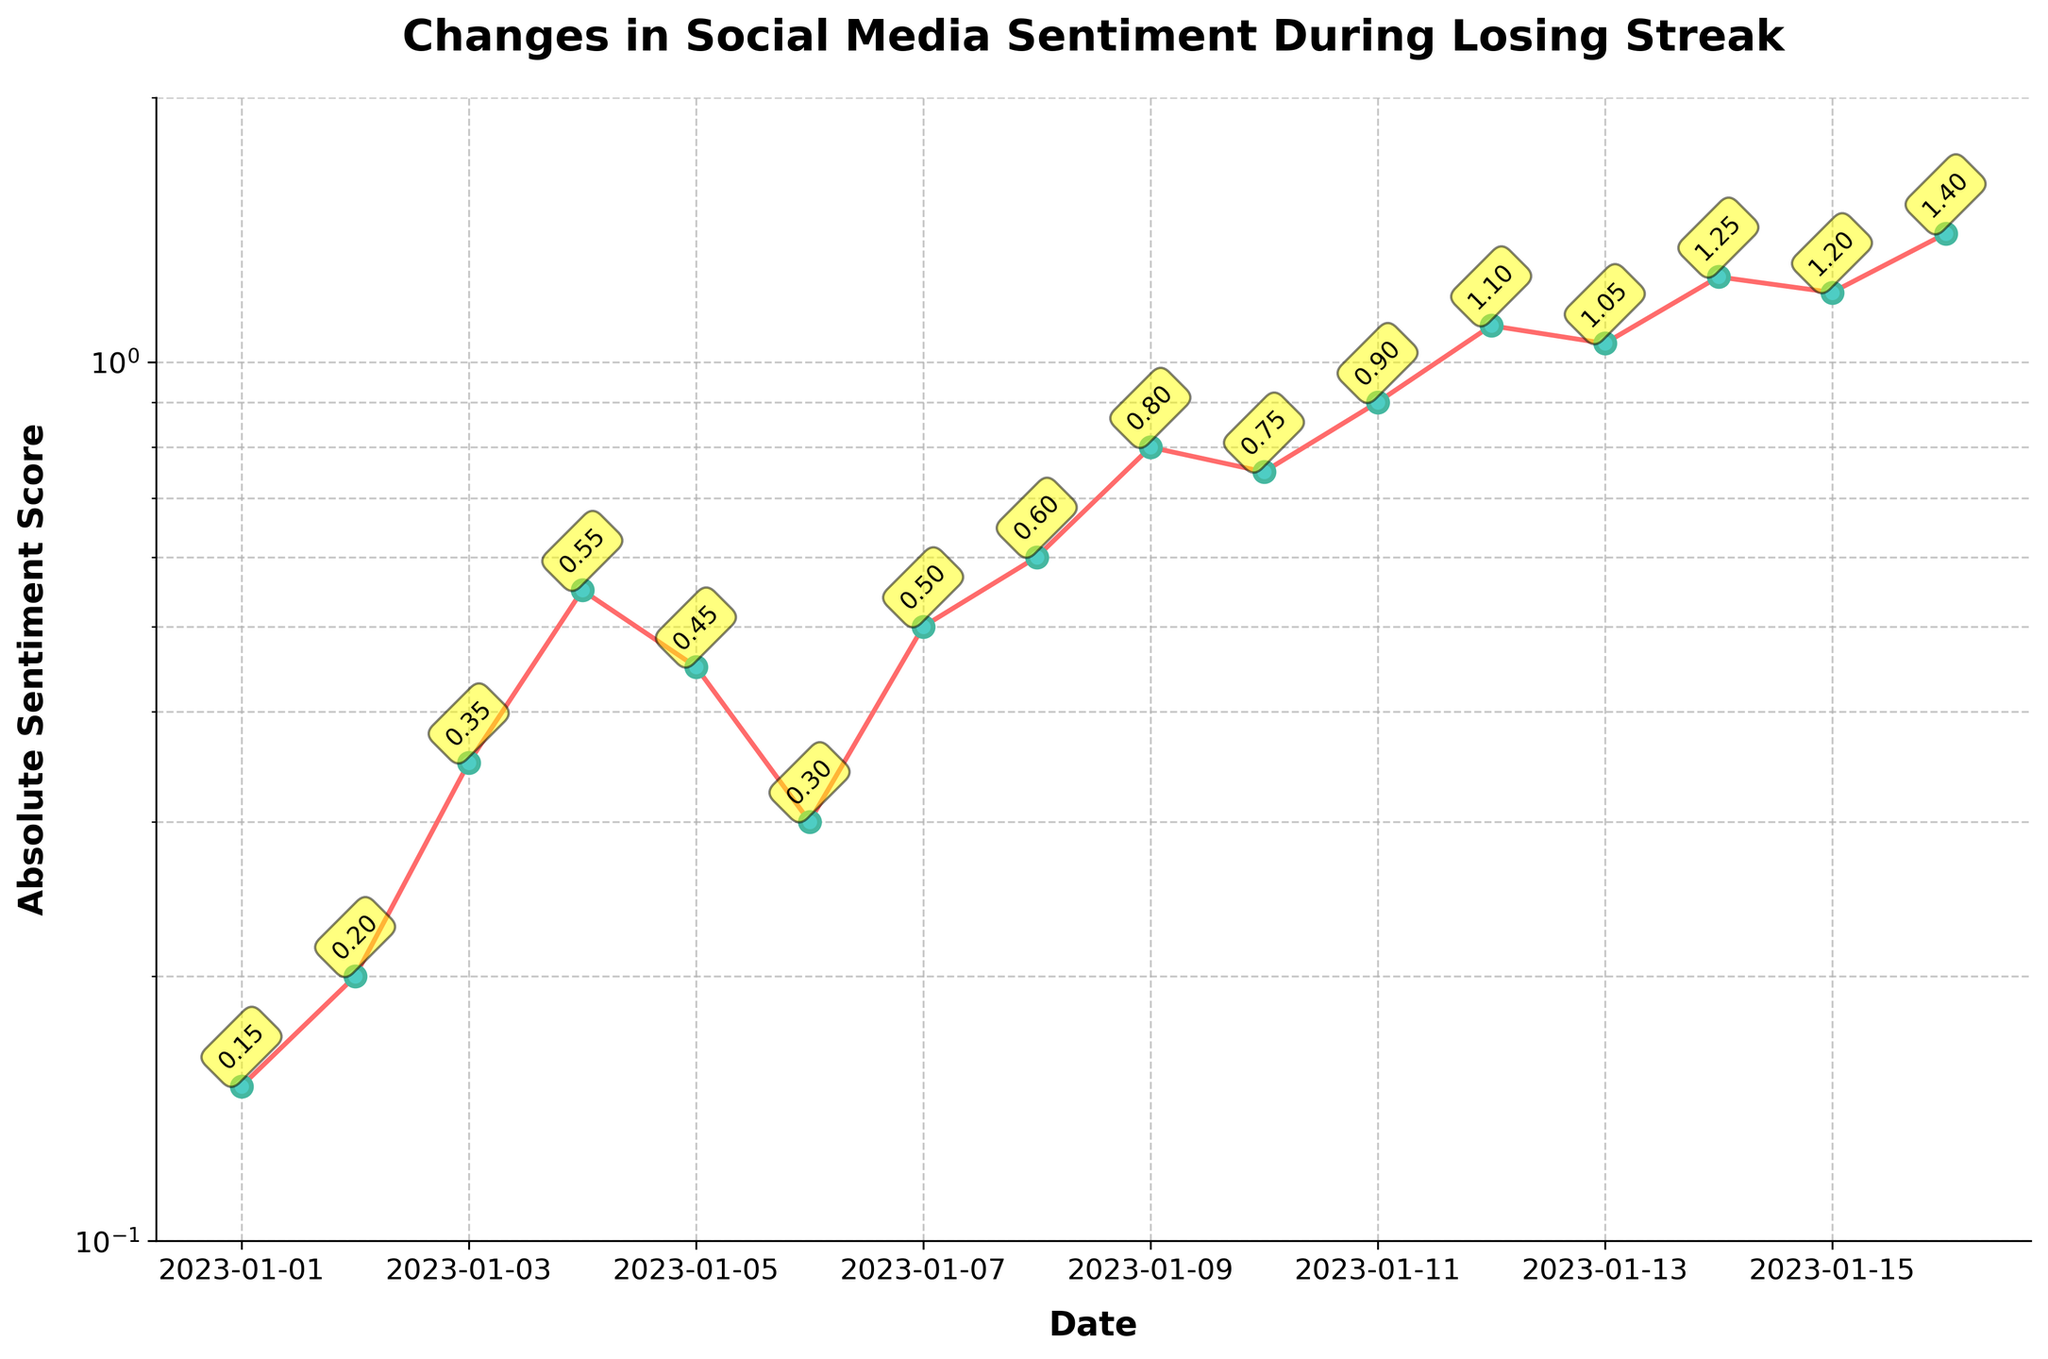What is the title of the plot? The title of the plot is located at the top and reads "Changes in Social Media Sentiment During Losing Streak".
Answer: Changes in Social Media Sentiment During Losing Streak What are the labels on the x-axis and y-axis? The x-axis label is "Date" and the y-axis label is "Absolute Sentiment Score".
Answer: Date and Absolute Sentiment Score How many data points are plotted on the graph? There are date markers from January 1st, 2023 to January 16th, 2023 on the x-axis, indicating that there are 16 data points plotted.
Answer: 16 Which color are the line and markers? The line is red, and the markers are cyan with green edges.
Answer: Red and Cyan What is the y-scale used in the plot? The y-axis of the plot uses a log scale, as indicated by the logarithmic spacing of the tick marks.
Answer: Log scale What is the average absolute sentiment score over the first 5 days? Averaging the absolute sentiment scores for the first five dates (0.15 + 0.20 + 0.35 + 0.55 + 0.45) gives (0.15 + 0.20 + 0.35 + 0.55 + 0.45)/5 = 0.34.
Answer: 0.34 What is the difference in absolute sentiment score between January 12th and January 1st? The absolute sentiment score on January 12th is 1.10 and on January 1st is 0.15. The difference is 1.10 - 0.15 = 0.95.
Answer: 0.95 On what date does the absolute sentiment score first exceed 1.0? The plot shows that the absolute sentiment score first exceeds 1.0 on January 12th, 2023.
Answer: January 12th, 2023 Which day shows the highest absolute sentiment score? The highest absolute sentiment score on the plot is recorded on January 16th, 2023, with a value of 1.40.
Answer: January 16th, 2023 Between January 6th and January 8th, which day has the highest absolute sentiment score? The absolute sentiment scores on January 6th, January 7th, and January 8th are 0.30, 0.50, and 0.60 respectively. January 8th has the highest absolute sentiment score.
Answer: January 8th How does the absolute sentiment score change as the losing streak progresses? The absolute sentiment score generally increases as the losing streak progresses, which is indicative of worsening or increasingly negative sentiment over time.
Answer: Increases How does the log scale on the y-axis affect the appearance of the changes in sentiment scores over time? The log scale on the y-axis makes changes in sentiment scores near the lower end (e.g., between 0.1 to 1.0) appear more pronounced and emphasizes the relative differences between higher sentiment scores more effectively.
Answer: Makes changes appear more pronounced At which two dates is the change in absolute sentiment score the most drastic? Examining the slopes between each pair of data points, the most drastic change occurs between January 3rd and January 4th, going from 0.35 to 0.55, and between January 10th and January 11th, going from 0.75 to 0.90.
Answer: January 3rd to January 4th, and January 10th to January 11th 